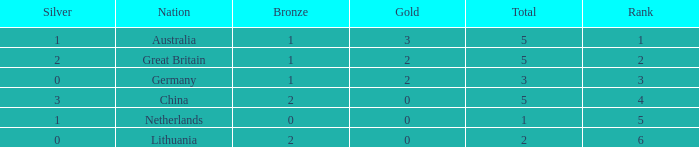What is the average Rank when there are 2 bronze, the total is 2 and gold is less than 0? None. 